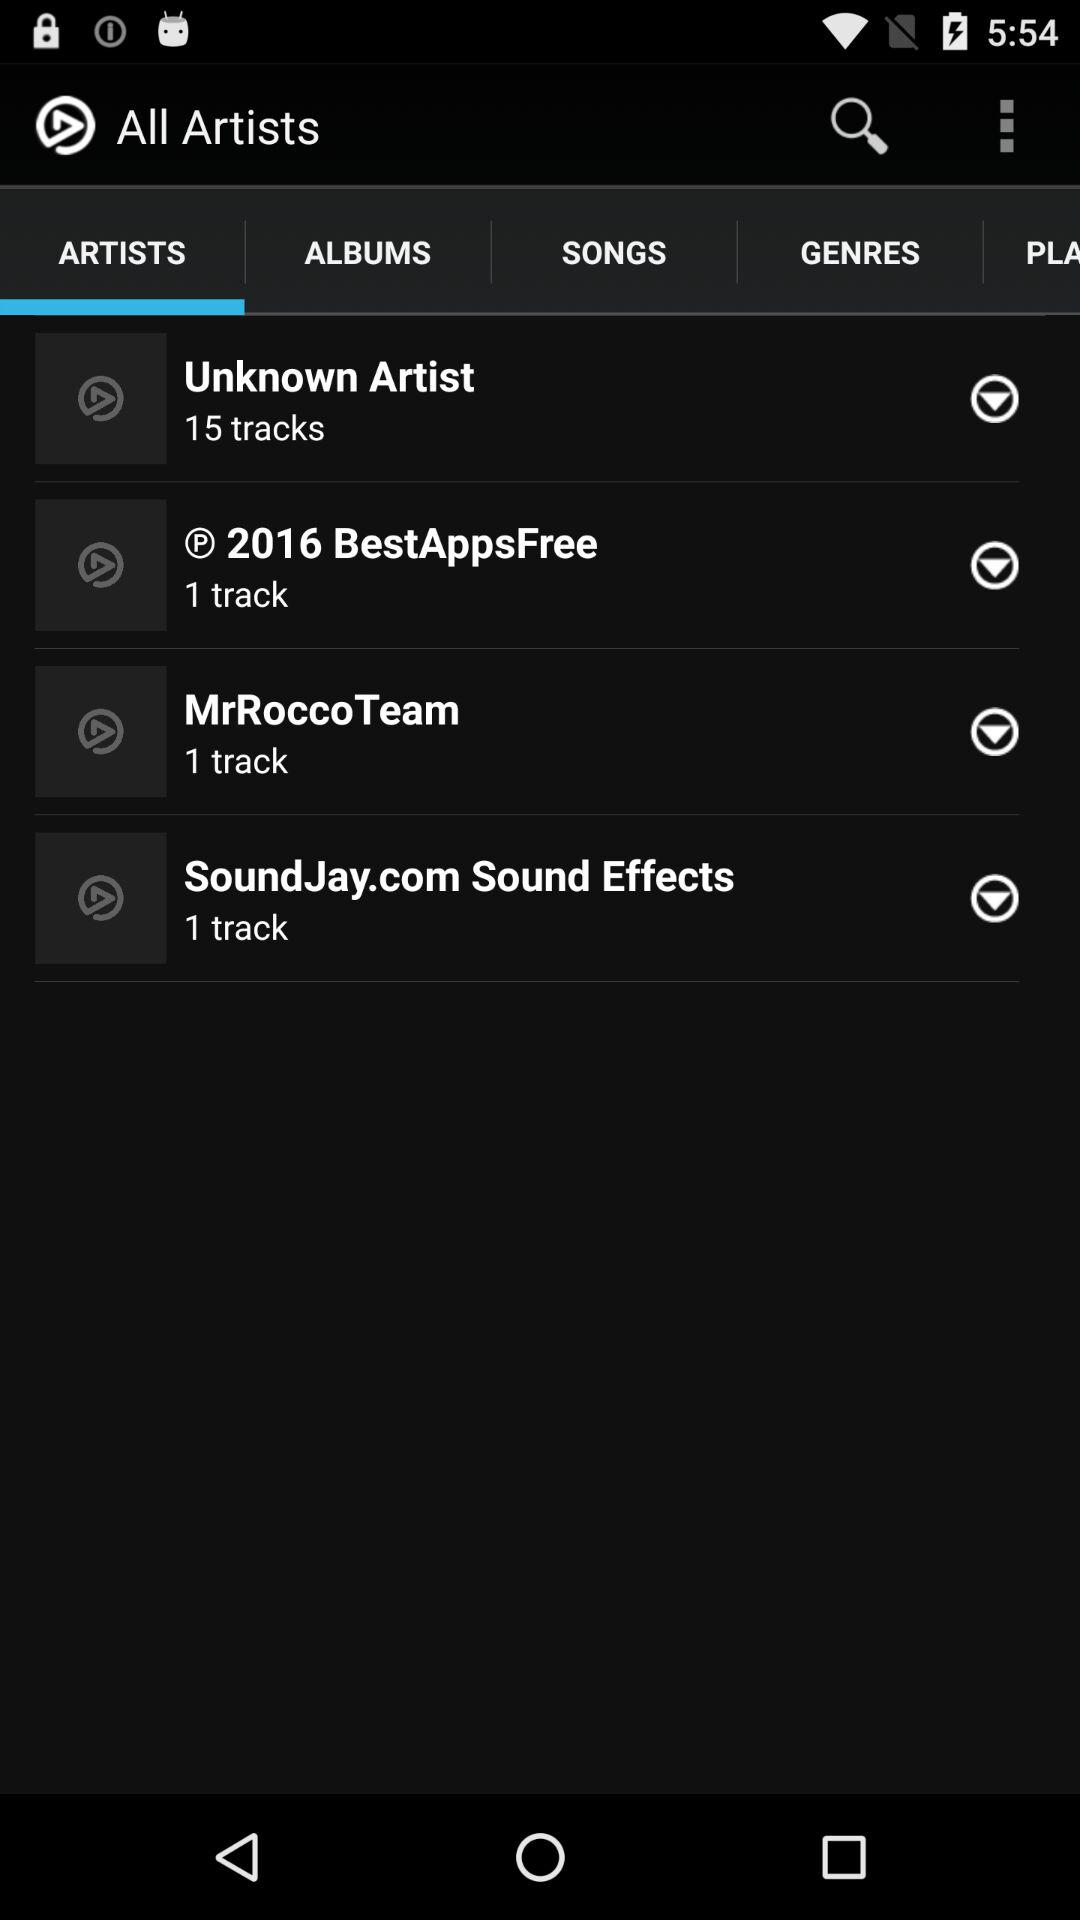How many tracks are there in "MrRocco Team"? There is 1 track. 